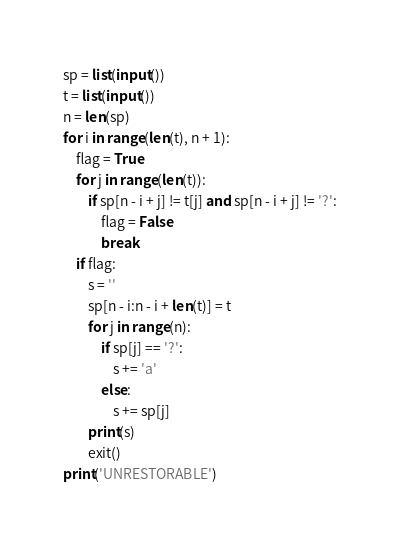<code> <loc_0><loc_0><loc_500><loc_500><_Python_>sp = list(input())
t = list(input())
n = len(sp)
for i in range(len(t), n + 1):
    flag = True
    for j in range(len(t)):
        if sp[n - i + j] != t[j] and sp[n - i + j] != '?':
            flag = False
            break
    if flag:
        s = ''
        sp[n - i:n - i + len(t)] = t
        for j in range(n):
            if sp[j] == '?':
                s += 'a'
            else:
                s += sp[j]
        print(s)
        exit()
print('UNRESTORABLE')
</code> 